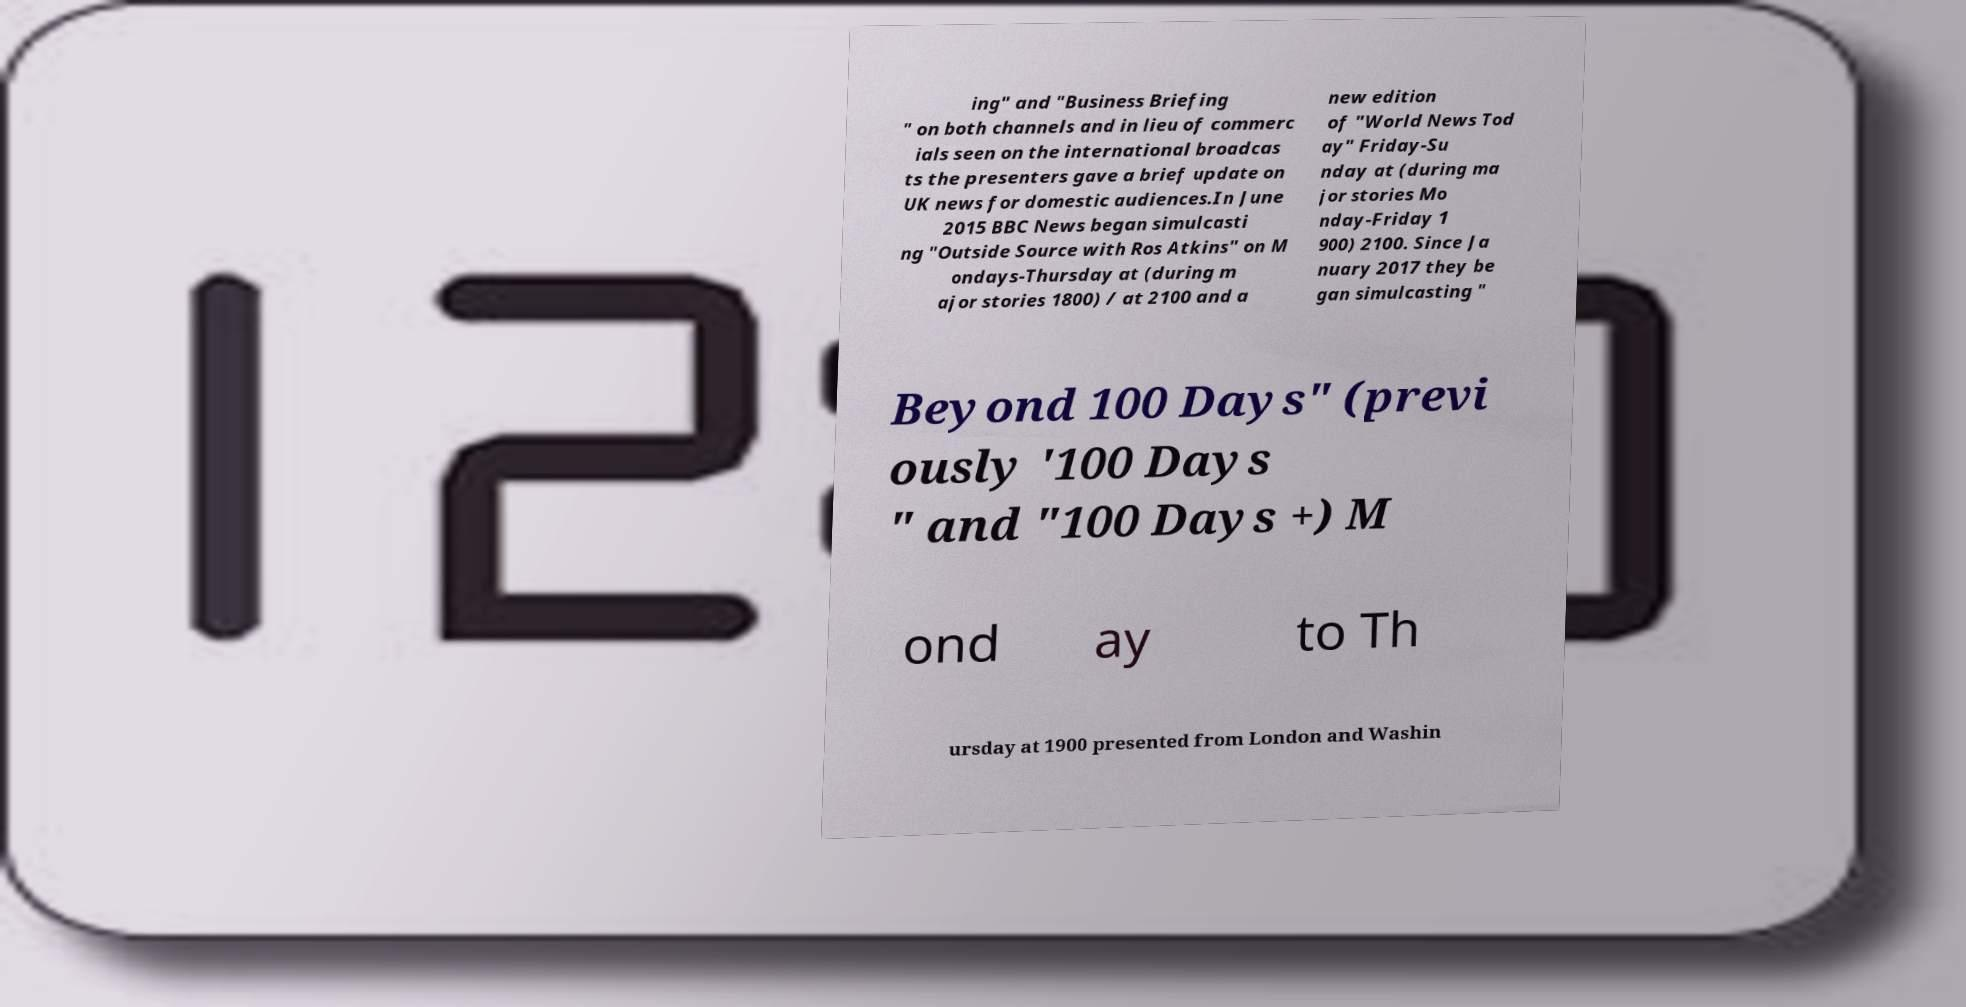Please read and relay the text visible in this image. What does it say? ing" and "Business Briefing " on both channels and in lieu of commerc ials seen on the international broadcas ts the presenters gave a brief update on UK news for domestic audiences.In June 2015 BBC News began simulcasti ng "Outside Source with Ros Atkins" on M ondays-Thursday at (during m ajor stories 1800) / at 2100 and a new edition of "World News Tod ay" Friday-Su nday at (during ma jor stories Mo nday-Friday 1 900) 2100. Since Ja nuary 2017 they be gan simulcasting " Beyond 100 Days" (previ ously '100 Days " and "100 Days +) M ond ay to Th ursday at 1900 presented from London and Washin 